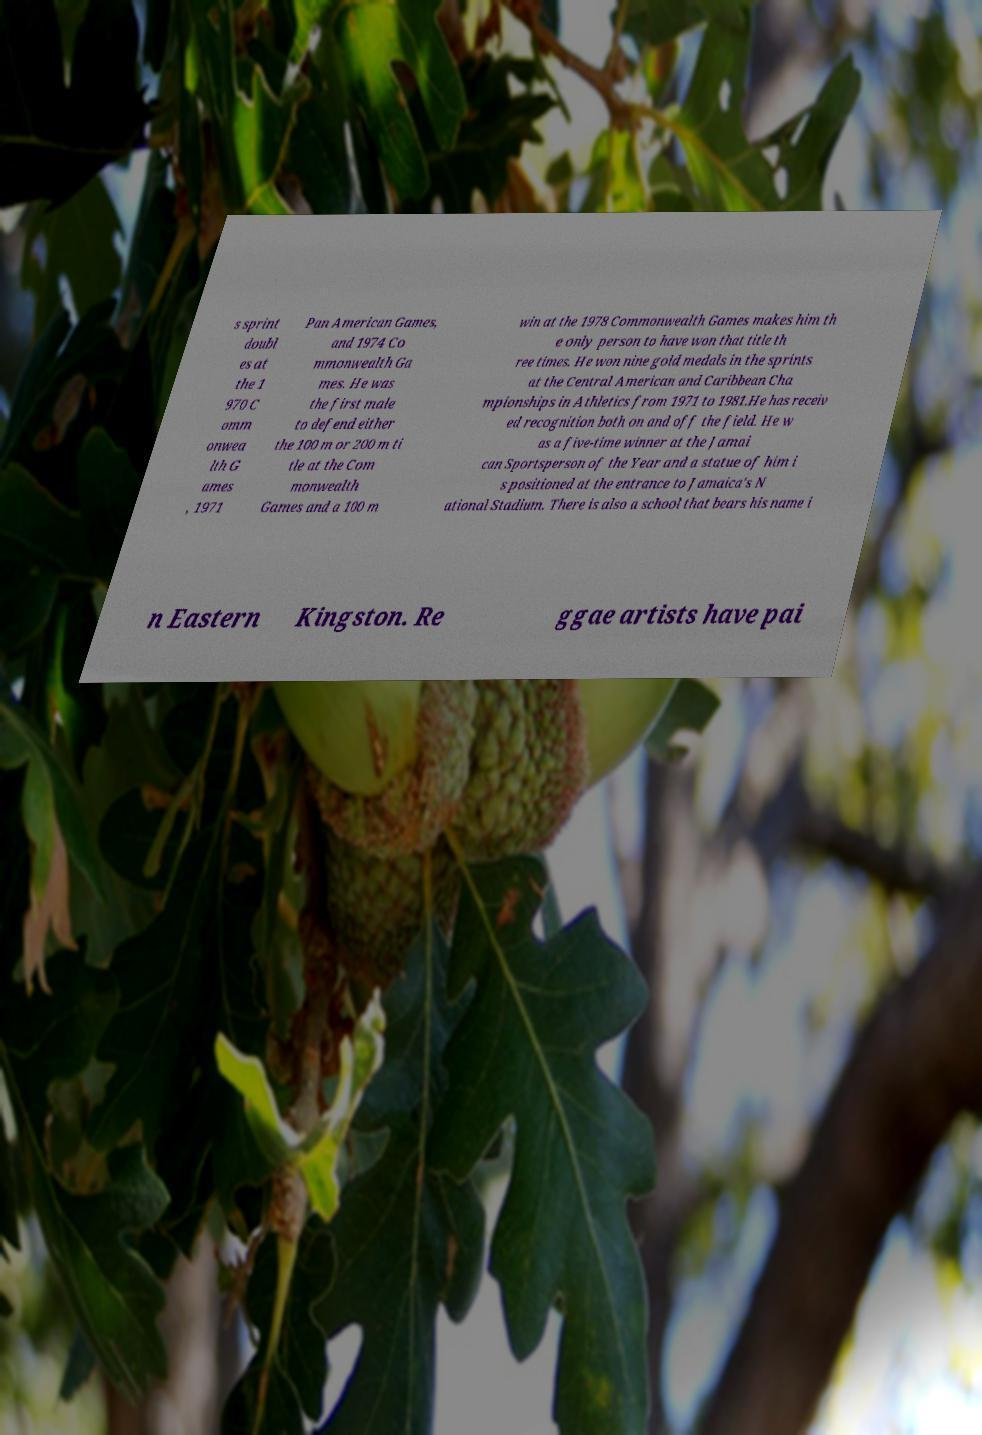Could you extract and type out the text from this image? s sprint doubl es at the 1 970 C omm onwea lth G ames , 1971 Pan American Games, and 1974 Co mmonwealth Ga mes. He was the first male to defend either the 100 m or 200 m ti tle at the Com monwealth Games and a 100 m win at the 1978 Commonwealth Games makes him th e only person to have won that title th ree times. He won nine gold medals in the sprints at the Central American and Caribbean Cha mpionships in Athletics from 1971 to 1981.He has receiv ed recognition both on and off the field. He w as a five-time winner at the Jamai can Sportsperson of the Year and a statue of him i s positioned at the entrance to Jamaica's N ational Stadium. There is also a school that bears his name i n Eastern Kingston. Re ggae artists have pai 